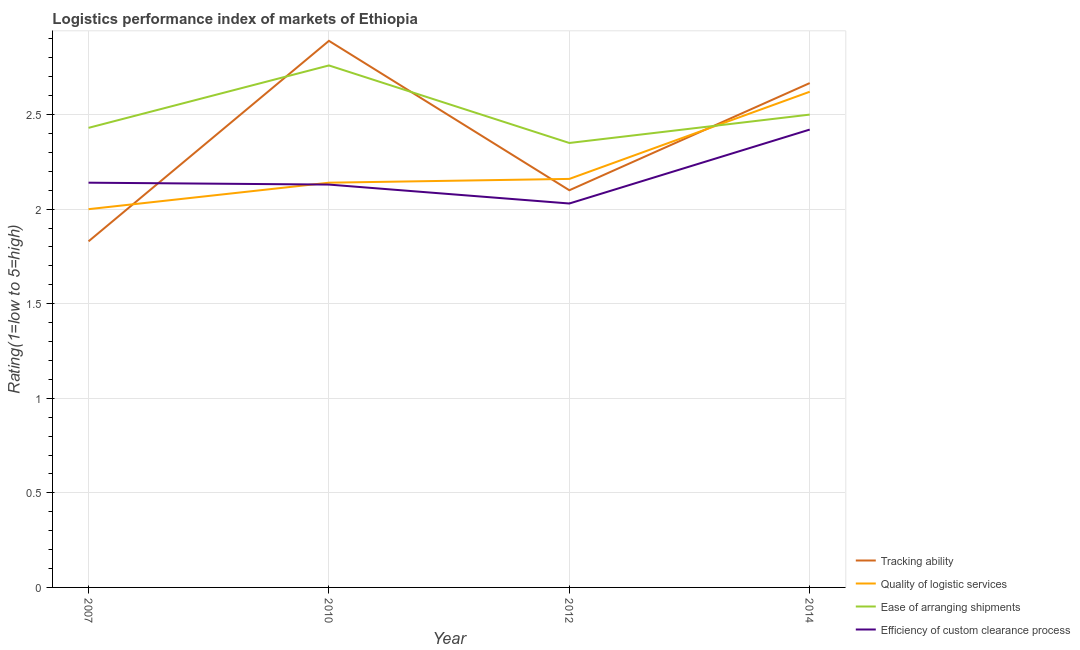How many different coloured lines are there?
Make the answer very short. 4. Does the line corresponding to lpi rating of ease of arranging shipments intersect with the line corresponding to lpi rating of quality of logistic services?
Give a very brief answer. Yes. What is the lpi rating of tracking ability in 2010?
Your answer should be compact. 2.89. Across all years, what is the maximum lpi rating of tracking ability?
Offer a terse response. 2.89. Across all years, what is the minimum lpi rating of quality of logistic services?
Keep it short and to the point. 2. In which year was the lpi rating of quality of logistic services maximum?
Your response must be concise. 2014. In which year was the lpi rating of efficiency of custom clearance process minimum?
Give a very brief answer. 2012. What is the total lpi rating of ease of arranging shipments in the graph?
Offer a very short reply. 10.04. What is the difference between the lpi rating of tracking ability in 2007 and that in 2010?
Keep it short and to the point. -1.06. What is the difference between the lpi rating of quality of logistic services in 2014 and the lpi rating of ease of arranging shipments in 2010?
Offer a very short reply. -0.14. What is the average lpi rating of tracking ability per year?
Ensure brevity in your answer.  2.37. In the year 2012, what is the difference between the lpi rating of ease of arranging shipments and lpi rating of quality of logistic services?
Offer a very short reply. 0.19. In how many years, is the lpi rating of quality of logistic services greater than 0.1?
Provide a short and direct response. 4. What is the ratio of the lpi rating of quality of logistic services in 2007 to that in 2014?
Your answer should be compact. 0.76. Is the lpi rating of ease of arranging shipments in 2007 less than that in 2010?
Your response must be concise. Yes. What is the difference between the highest and the second highest lpi rating of quality of logistic services?
Offer a very short reply. 0.46. What is the difference between the highest and the lowest lpi rating of quality of logistic services?
Your answer should be compact. 0.62. Is the sum of the lpi rating of efficiency of custom clearance process in 2007 and 2012 greater than the maximum lpi rating of ease of arranging shipments across all years?
Provide a short and direct response. Yes. Is it the case that in every year, the sum of the lpi rating of ease of arranging shipments and lpi rating of quality of logistic services is greater than the sum of lpi rating of efficiency of custom clearance process and lpi rating of tracking ability?
Make the answer very short. No. Is it the case that in every year, the sum of the lpi rating of tracking ability and lpi rating of quality of logistic services is greater than the lpi rating of ease of arranging shipments?
Offer a very short reply. Yes. Is the lpi rating of ease of arranging shipments strictly less than the lpi rating of quality of logistic services over the years?
Offer a very short reply. No. How many lines are there?
Make the answer very short. 4. What is the difference between two consecutive major ticks on the Y-axis?
Keep it short and to the point. 0.5. Does the graph contain any zero values?
Keep it short and to the point. No. Does the graph contain grids?
Provide a succinct answer. Yes. Where does the legend appear in the graph?
Give a very brief answer. Bottom right. How many legend labels are there?
Provide a short and direct response. 4. How are the legend labels stacked?
Your response must be concise. Vertical. What is the title of the graph?
Keep it short and to the point. Logistics performance index of markets of Ethiopia. What is the label or title of the X-axis?
Your answer should be very brief. Year. What is the label or title of the Y-axis?
Make the answer very short. Rating(1=low to 5=high). What is the Rating(1=low to 5=high) in Tracking ability in 2007?
Provide a short and direct response. 1.83. What is the Rating(1=low to 5=high) in Ease of arranging shipments in 2007?
Offer a very short reply. 2.43. What is the Rating(1=low to 5=high) of Efficiency of custom clearance process in 2007?
Offer a very short reply. 2.14. What is the Rating(1=low to 5=high) in Tracking ability in 2010?
Keep it short and to the point. 2.89. What is the Rating(1=low to 5=high) in Quality of logistic services in 2010?
Offer a very short reply. 2.14. What is the Rating(1=low to 5=high) of Ease of arranging shipments in 2010?
Provide a short and direct response. 2.76. What is the Rating(1=low to 5=high) of Efficiency of custom clearance process in 2010?
Ensure brevity in your answer.  2.13. What is the Rating(1=low to 5=high) of Quality of logistic services in 2012?
Keep it short and to the point. 2.16. What is the Rating(1=low to 5=high) in Ease of arranging shipments in 2012?
Provide a short and direct response. 2.35. What is the Rating(1=low to 5=high) in Efficiency of custom clearance process in 2012?
Provide a short and direct response. 2.03. What is the Rating(1=low to 5=high) of Tracking ability in 2014?
Provide a short and direct response. 2.67. What is the Rating(1=low to 5=high) of Quality of logistic services in 2014?
Provide a succinct answer. 2.62. What is the Rating(1=low to 5=high) in Ease of arranging shipments in 2014?
Offer a very short reply. 2.5. What is the Rating(1=low to 5=high) in Efficiency of custom clearance process in 2014?
Provide a short and direct response. 2.42. Across all years, what is the maximum Rating(1=low to 5=high) in Tracking ability?
Keep it short and to the point. 2.89. Across all years, what is the maximum Rating(1=low to 5=high) of Quality of logistic services?
Your answer should be very brief. 2.62. Across all years, what is the maximum Rating(1=low to 5=high) in Ease of arranging shipments?
Ensure brevity in your answer.  2.76. Across all years, what is the maximum Rating(1=low to 5=high) in Efficiency of custom clearance process?
Your answer should be compact. 2.42. Across all years, what is the minimum Rating(1=low to 5=high) in Tracking ability?
Make the answer very short. 1.83. Across all years, what is the minimum Rating(1=low to 5=high) of Quality of logistic services?
Provide a succinct answer. 2. Across all years, what is the minimum Rating(1=low to 5=high) in Ease of arranging shipments?
Offer a terse response. 2.35. Across all years, what is the minimum Rating(1=low to 5=high) of Efficiency of custom clearance process?
Provide a succinct answer. 2.03. What is the total Rating(1=low to 5=high) of Tracking ability in the graph?
Provide a succinct answer. 9.49. What is the total Rating(1=low to 5=high) in Quality of logistic services in the graph?
Your response must be concise. 8.92. What is the total Rating(1=low to 5=high) in Ease of arranging shipments in the graph?
Provide a succinct answer. 10.04. What is the total Rating(1=low to 5=high) in Efficiency of custom clearance process in the graph?
Provide a succinct answer. 8.72. What is the difference between the Rating(1=low to 5=high) in Tracking ability in 2007 and that in 2010?
Make the answer very short. -1.06. What is the difference between the Rating(1=low to 5=high) of Quality of logistic services in 2007 and that in 2010?
Provide a short and direct response. -0.14. What is the difference between the Rating(1=low to 5=high) in Ease of arranging shipments in 2007 and that in 2010?
Give a very brief answer. -0.33. What is the difference between the Rating(1=low to 5=high) in Efficiency of custom clearance process in 2007 and that in 2010?
Ensure brevity in your answer.  0.01. What is the difference between the Rating(1=low to 5=high) of Tracking ability in 2007 and that in 2012?
Give a very brief answer. -0.27. What is the difference between the Rating(1=low to 5=high) of Quality of logistic services in 2007 and that in 2012?
Provide a short and direct response. -0.16. What is the difference between the Rating(1=low to 5=high) of Ease of arranging shipments in 2007 and that in 2012?
Keep it short and to the point. 0.08. What is the difference between the Rating(1=low to 5=high) in Efficiency of custom clearance process in 2007 and that in 2012?
Provide a short and direct response. 0.11. What is the difference between the Rating(1=low to 5=high) of Tracking ability in 2007 and that in 2014?
Your response must be concise. -0.84. What is the difference between the Rating(1=low to 5=high) of Quality of logistic services in 2007 and that in 2014?
Provide a short and direct response. -0.62. What is the difference between the Rating(1=low to 5=high) in Ease of arranging shipments in 2007 and that in 2014?
Ensure brevity in your answer.  -0.07. What is the difference between the Rating(1=low to 5=high) in Efficiency of custom clearance process in 2007 and that in 2014?
Give a very brief answer. -0.28. What is the difference between the Rating(1=low to 5=high) of Tracking ability in 2010 and that in 2012?
Your answer should be compact. 0.79. What is the difference between the Rating(1=low to 5=high) of Quality of logistic services in 2010 and that in 2012?
Offer a very short reply. -0.02. What is the difference between the Rating(1=low to 5=high) in Ease of arranging shipments in 2010 and that in 2012?
Make the answer very short. 0.41. What is the difference between the Rating(1=low to 5=high) of Tracking ability in 2010 and that in 2014?
Ensure brevity in your answer.  0.22. What is the difference between the Rating(1=low to 5=high) in Quality of logistic services in 2010 and that in 2014?
Keep it short and to the point. -0.48. What is the difference between the Rating(1=low to 5=high) of Ease of arranging shipments in 2010 and that in 2014?
Your response must be concise. 0.26. What is the difference between the Rating(1=low to 5=high) in Efficiency of custom clearance process in 2010 and that in 2014?
Give a very brief answer. -0.29. What is the difference between the Rating(1=low to 5=high) of Tracking ability in 2012 and that in 2014?
Your response must be concise. -0.57. What is the difference between the Rating(1=low to 5=high) of Quality of logistic services in 2012 and that in 2014?
Provide a succinct answer. -0.46. What is the difference between the Rating(1=low to 5=high) of Efficiency of custom clearance process in 2012 and that in 2014?
Your response must be concise. -0.39. What is the difference between the Rating(1=low to 5=high) of Tracking ability in 2007 and the Rating(1=low to 5=high) of Quality of logistic services in 2010?
Provide a short and direct response. -0.31. What is the difference between the Rating(1=low to 5=high) in Tracking ability in 2007 and the Rating(1=low to 5=high) in Ease of arranging shipments in 2010?
Ensure brevity in your answer.  -0.93. What is the difference between the Rating(1=low to 5=high) of Tracking ability in 2007 and the Rating(1=low to 5=high) of Efficiency of custom clearance process in 2010?
Offer a terse response. -0.3. What is the difference between the Rating(1=low to 5=high) of Quality of logistic services in 2007 and the Rating(1=low to 5=high) of Ease of arranging shipments in 2010?
Your answer should be very brief. -0.76. What is the difference between the Rating(1=low to 5=high) in Quality of logistic services in 2007 and the Rating(1=low to 5=high) in Efficiency of custom clearance process in 2010?
Ensure brevity in your answer.  -0.13. What is the difference between the Rating(1=low to 5=high) of Ease of arranging shipments in 2007 and the Rating(1=low to 5=high) of Efficiency of custom clearance process in 2010?
Keep it short and to the point. 0.3. What is the difference between the Rating(1=low to 5=high) of Tracking ability in 2007 and the Rating(1=low to 5=high) of Quality of logistic services in 2012?
Offer a very short reply. -0.33. What is the difference between the Rating(1=low to 5=high) of Tracking ability in 2007 and the Rating(1=low to 5=high) of Ease of arranging shipments in 2012?
Keep it short and to the point. -0.52. What is the difference between the Rating(1=low to 5=high) in Quality of logistic services in 2007 and the Rating(1=low to 5=high) in Ease of arranging shipments in 2012?
Keep it short and to the point. -0.35. What is the difference between the Rating(1=low to 5=high) in Quality of logistic services in 2007 and the Rating(1=low to 5=high) in Efficiency of custom clearance process in 2012?
Offer a very short reply. -0.03. What is the difference between the Rating(1=low to 5=high) in Tracking ability in 2007 and the Rating(1=low to 5=high) in Quality of logistic services in 2014?
Your answer should be compact. -0.79. What is the difference between the Rating(1=low to 5=high) of Tracking ability in 2007 and the Rating(1=low to 5=high) of Ease of arranging shipments in 2014?
Your answer should be very brief. -0.67. What is the difference between the Rating(1=low to 5=high) in Tracking ability in 2007 and the Rating(1=low to 5=high) in Efficiency of custom clearance process in 2014?
Provide a short and direct response. -0.59. What is the difference between the Rating(1=low to 5=high) of Quality of logistic services in 2007 and the Rating(1=low to 5=high) of Efficiency of custom clearance process in 2014?
Make the answer very short. -0.42. What is the difference between the Rating(1=low to 5=high) of Ease of arranging shipments in 2007 and the Rating(1=low to 5=high) of Efficiency of custom clearance process in 2014?
Keep it short and to the point. 0.01. What is the difference between the Rating(1=low to 5=high) of Tracking ability in 2010 and the Rating(1=low to 5=high) of Quality of logistic services in 2012?
Offer a very short reply. 0.73. What is the difference between the Rating(1=low to 5=high) of Tracking ability in 2010 and the Rating(1=low to 5=high) of Ease of arranging shipments in 2012?
Your response must be concise. 0.54. What is the difference between the Rating(1=low to 5=high) of Tracking ability in 2010 and the Rating(1=low to 5=high) of Efficiency of custom clearance process in 2012?
Give a very brief answer. 0.86. What is the difference between the Rating(1=low to 5=high) of Quality of logistic services in 2010 and the Rating(1=low to 5=high) of Ease of arranging shipments in 2012?
Offer a terse response. -0.21. What is the difference between the Rating(1=low to 5=high) in Quality of logistic services in 2010 and the Rating(1=low to 5=high) in Efficiency of custom clearance process in 2012?
Keep it short and to the point. 0.11. What is the difference between the Rating(1=low to 5=high) of Ease of arranging shipments in 2010 and the Rating(1=low to 5=high) of Efficiency of custom clearance process in 2012?
Your answer should be compact. 0.73. What is the difference between the Rating(1=low to 5=high) in Tracking ability in 2010 and the Rating(1=low to 5=high) in Quality of logistic services in 2014?
Your answer should be compact. 0.27. What is the difference between the Rating(1=low to 5=high) of Tracking ability in 2010 and the Rating(1=low to 5=high) of Ease of arranging shipments in 2014?
Offer a terse response. 0.39. What is the difference between the Rating(1=low to 5=high) in Tracking ability in 2010 and the Rating(1=low to 5=high) in Efficiency of custom clearance process in 2014?
Offer a very short reply. 0.47. What is the difference between the Rating(1=low to 5=high) in Quality of logistic services in 2010 and the Rating(1=low to 5=high) in Ease of arranging shipments in 2014?
Offer a very short reply. -0.36. What is the difference between the Rating(1=low to 5=high) in Quality of logistic services in 2010 and the Rating(1=low to 5=high) in Efficiency of custom clearance process in 2014?
Give a very brief answer. -0.28. What is the difference between the Rating(1=low to 5=high) in Ease of arranging shipments in 2010 and the Rating(1=low to 5=high) in Efficiency of custom clearance process in 2014?
Offer a terse response. 0.34. What is the difference between the Rating(1=low to 5=high) in Tracking ability in 2012 and the Rating(1=low to 5=high) in Quality of logistic services in 2014?
Your answer should be compact. -0.52. What is the difference between the Rating(1=low to 5=high) of Tracking ability in 2012 and the Rating(1=low to 5=high) of Efficiency of custom clearance process in 2014?
Offer a terse response. -0.32. What is the difference between the Rating(1=low to 5=high) in Quality of logistic services in 2012 and the Rating(1=low to 5=high) in Ease of arranging shipments in 2014?
Offer a terse response. -0.34. What is the difference between the Rating(1=low to 5=high) of Quality of logistic services in 2012 and the Rating(1=low to 5=high) of Efficiency of custom clearance process in 2014?
Your answer should be very brief. -0.26. What is the difference between the Rating(1=low to 5=high) in Ease of arranging shipments in 2012 and the Rating(1=low to 5=high) in Efficiency of custom clearance process in 2014?
Keep it short and to the point. -0.07. What is the average Rating(1=low to 5=high) of Tracking ability per year?
Make the answer very short. 2.37. What is the average Rating(1=low to 5=high) in Quality of logistic services per year?
Your answer should be very brief. 2.23. What is the average Rating(1=low to 5=high) of Ease of arranging shipments per year?
Provide a succinct answer. 2.51. What is the average Rating(1=low to 5=high) in Efficiency of custom clearance process per year?
Provide a short and direct response. 2.18. In the year 2007, what is the difference between the Rating(1=low to 5=high) in Tracking ability and Rating(1=low to 5=high) in Quality of logistic services?
Provide a succinct answer. -0.17. In the year 2007, what is the difference between the Rating(1=low to 5=high) in Tracking ability and Rating(1=low to 5=high) in Ease of arranging shipments?
Keep it short and to the point. -0.6. In the year 2007, what is the difference between the Rating(1=low to 5=high) of Tracking ability and Rating(1=low to 5=high) of Efficiency of custom clearance process?
Offer a very short reply. -0.31. In the year 2007, what is the difference between the Rating(1=low to 5=high) of Quality of logistic services and Rating(1=low to 5=high) of Ease of arranging shipments?
Ensure brevity in your answer.  -0.43. In the year 2007, what is the difference between the Rating(1=low to 5=high) of Quality of logistic services and Rating(1=low to 5=high) of Efficiency of custom clearance process?
Your answer should be compact. -0.14. In the year 2007, what is the difference between the Rating(1=low to 5=high) in Ease of arranging shipments and Rating(1=low to 5=high) in Efficiency of custom clearance process?
Give a very brief answer. 0.29. In the year 2010, what is the difference between the Rating(1=low to 5=high) of Tracking ability and Rating(1=low to 5=high) of Ease of arranging shipments?
Ensure brevity in your answer.  0.13. In the year 2010, what is the difference between the Rating(1=low to 5=high) in Tracking ability and Rating(1=low to 5=high) in Efficiency of custom clearance process?
Keep it short and to the point. 0.76. In the year 2010, what is the difference between the Rating(1=low to 5=high) in Quality of logistic services and Rating(1=low to 5=high) in Ease of arranging shipments?
Keep it short and to the point. -0.62. In the year 2010, what is the difference between the Rating(1=low to 5=high) of Quality of logistic services and Rating(1=low to 5=high) of Efficiency of custom clearance process?
Your answer should be very brief. 0.01. In the year 2010, what is the difference between the Rating(1=low to 5=high) in Ease of arranging shipments and Rating(1=low to 5=high) in Efficiency of custom clearance process?
Ensure brevity in your answer.  0.63. In the year 2012, what is the difference between the Rating(1=low to 5=high) in Tracking ability and Rating(1=low to 5=high) in Quality of logistic services?
Your answer should be very brief. -0.06. In the year 2012, what is the difference between the Rating(1=low to 5=high) in Tracking ability and Rating(1=low to 5=high) in Ease of arranging shipments?
Ensure brevity in your answer.  -0.25. In the year 2012, what is the difference between the Rating(1=low to 5=high) in Tracking ability and Rating(1=low to 5=high) in Efficiency of custom clearance process?
Give a very brief answer. 0.07. In the year 2012, what is the difference between the Rating(1=low to 5=high) of Quality of logistic services and Rating(1=low to 5=high) of Ease of arranging shipments?
Your answer should be very brief. -0.19. In the year 2012, what is the difference between the Rating(1=low to 5=high) of Quality of logistic services and Rating(1=low to 5=high) of Efficiency of custom clearance process?
Your answer should be compact. 0.13. In the year 2012, what is the difference between the Rating(1=low to 5=high) of Ease of arranging shipments and Rating(1=low to 5=high) of Efficiency of custom clearance process?
Make the answer very short. 0.32. In the year 2014, what is the difference between the Rating(1=low to 5=high) of Tracking ability and Rating(1=low to 5=high) of Quality of logistic services?
Make the answer very short. 0.05. In the year 2014, what is the difference between the Rating(1=low to 5=high) of Tracking ability and Rating(1=low to 5=high) of Ease of arranging shipments?
Offer a terse response. 0.17. In the year 2014, what is the difference between the Rating(1=low to 5=high) in Tracking ability and Rating(1=low to 5=high) in Efficiency of custom clearance process?
Your answer should be compact. 0.25. In the year 2014, what is the difference between the Rating(1=low to 5=high) of Quality of logistic services and Rating(1=low to 5=high) of Ease of arranging shipments?
Your answer should be compact. 0.12. In the year 2014, what is the difference between the Rating(1=low to 5=high) of Ease of arranging shipments and Rating(1=low to 5=high) of Efficiency of custom clearance process?
Keep it short and to the point. 0.08. What is the ratio of the Rating(1=low to 5=high) in Tracking ability in 2007 to that in 2010?
Offer a very short reply. 0.63. What is the ratio of the Rating(1=low to 5=high) of Quality of logistic services in 2007 to that in 2010?
Give a very brief answer. 0.93. What is the ratio of the Rating(1=low to 5=high) in Ease of arranging shipments in 2007 to that in 2010?
Offer a terse response. 0.88. What is the ratio of the Rating(1=low to 5=high) of Tracking ability in 2007 to that in 2012?
Your answer should be very brief. 0.87. What is the ratio of the Rating(1=low to 5=high) of Quality of logistic services in 2007 to that in 2012?
Your response must be concise. 0.93. What is the ratio of the Rating(1=low to 5=high) in Ease of arranging shipments in 2007 to that in 2012?
Make the answer very short. 1.03. What is the ratio of the Rating(1=low to 5=high) of Efficiency of custom clearance process in 2007 to that in 2012?
Offer a terse response. 1.05. What is the ratio of the Rating(1=low to 5=high) in Tracking ability in 2007 to that in 2014?
Your answer should be very brief. 0.69. What is the ratio of the Rating(1=low to 5=high) of Quality of logistic services in 2007 to that in 2014?
Ensure brevity in your answer.  0.76. What is the ratio of the Rating(1=low to 5=high) of Ease of arranging shipments in 2007 to that in 2014?
Your answer should be compact. 0.97. What is the ratio of the Rating(1=low to 5=high) of Efficiency of custom clearance process in 2007 to that in 2014?
Give a very brief answer. 0.88. What is the ratio of the Rating(1=low to 5=high) of Tracking ability in 2010 to that in 2012?
Provide a short and direct response. 1.38. What is the ratio of the Rating(1=low to 5=high) of Quality of logistic services in 2010 to that in 2012?
Your response must be concise. 0.99. What is the ratio of the Rating(1=low to 5=high) in Ease of arranging shipments in 2010 to that in 2012?
Your response must be concise. 1.17. What is the ratio of the Rating(1=low to 5=high) in Efficiency of custom clearance process in 2010 to that in 2012?
Keep it short and to the point. 1.05. What is the ratio of the Rating(1=low to 5=high) of Tracking ability in 2010 to that in 2014?
Your answer should be compact. 1.08. What is the ratio of the Rating(1=low to 5=high) of Quality of logistic services in 2010 to that in 2014?
Your response must be concise. 0.82. What is the ratio of the Rating(1=low to 5=high) in Ease of arranging shipments in 2010 to that in 2014?
Ensure brevity in your answer.  1.1. What is the ratio of the Rating(1=low to 5=high) in Efficiency of custom clearance process in 2010 to that in 2014?
Offer a very short reply. 0.88. What is the ratio of the Rating(1=low to 5=high) of Tracking ability in 2012 to that in 2014?
Offer a terse response. 0.79. What is the ratio of the Rating(1=low to 5=high) in Quality of logistic services in 2012 to that in 2014?
Keep it short and to the point. 0.82. What is the ratio of the Rating(1=low to 5=high) in Efficiency of custom clearance process in 2012 to that in 2014?
Your answer should be compact. 0.84. What is the difference between the highest and the second highest Rating(1=low to 5=high) in Tracking ability?
Make the answer very short. 0.22. What is the difference between the highest and the second highest Rating(1=low to 5=high) of Quality of logistic services?
Your response must be concise. 0.46. What is the difference between the highest and the second highest Rating(1=low to 5=high) in Ease of arranging shipments?
Your response must be concise. 0.26. What is the difference between the highest and the second highest Rating(1=low to 5=high) of Efficiency of custom clearance process?
Provide a succinct answer. 0.28. What is the difference between the highest and the lowest Rating(1=low to 5=high) of Tracking ability?
Provide a short and direct response. 1.06. What is the difference between the highest and the lowest Rating(1=low to 5=high) of Quality of logistic services?
Give a very brief answer. 0.62. What is the difference between the highest and the lowest Rating(1=low to 5=high) of Ease of arranging shipments?
Your answer should be compact. 0.41. What is the difference between the highest and the lowest Rating(1=low to 5=high) in Efficiency of custom clearance process?
Your response must be concise. 0.39. 